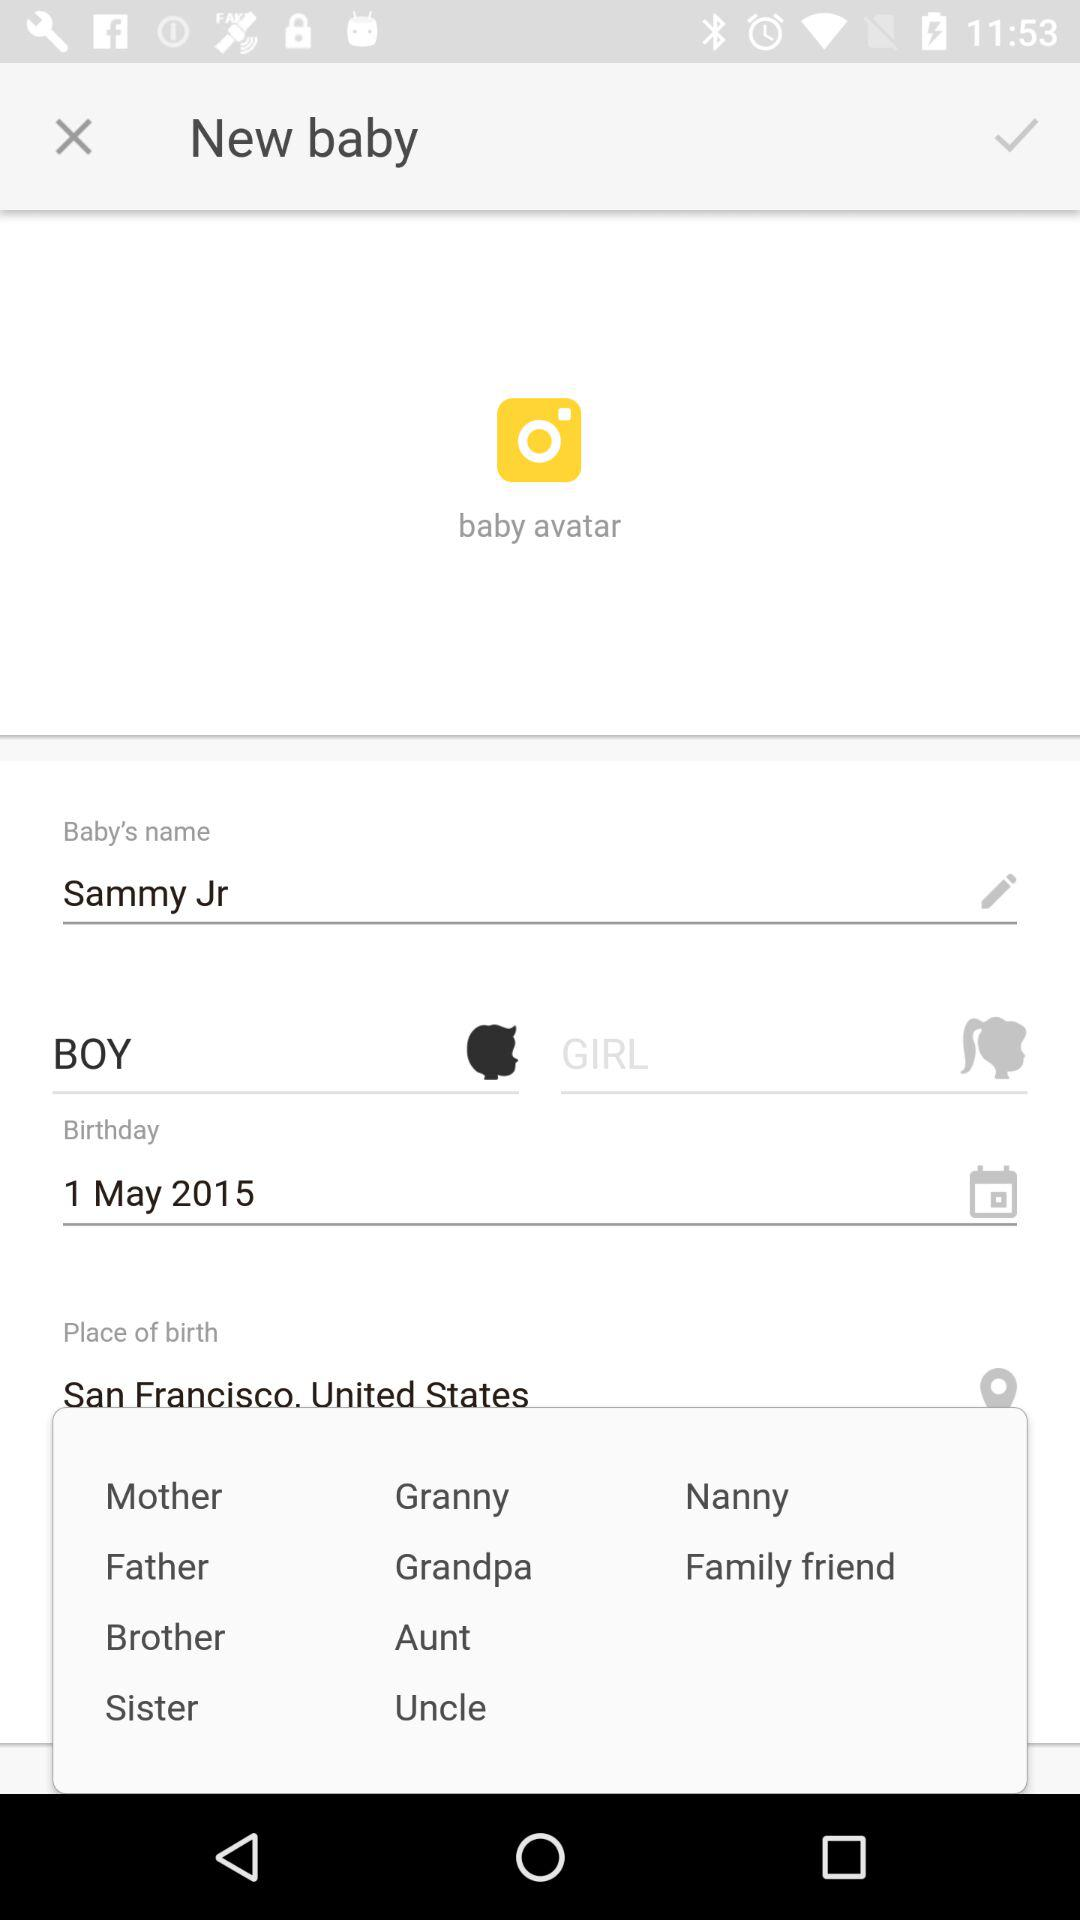What is the application name? The application name is "Instagram". 